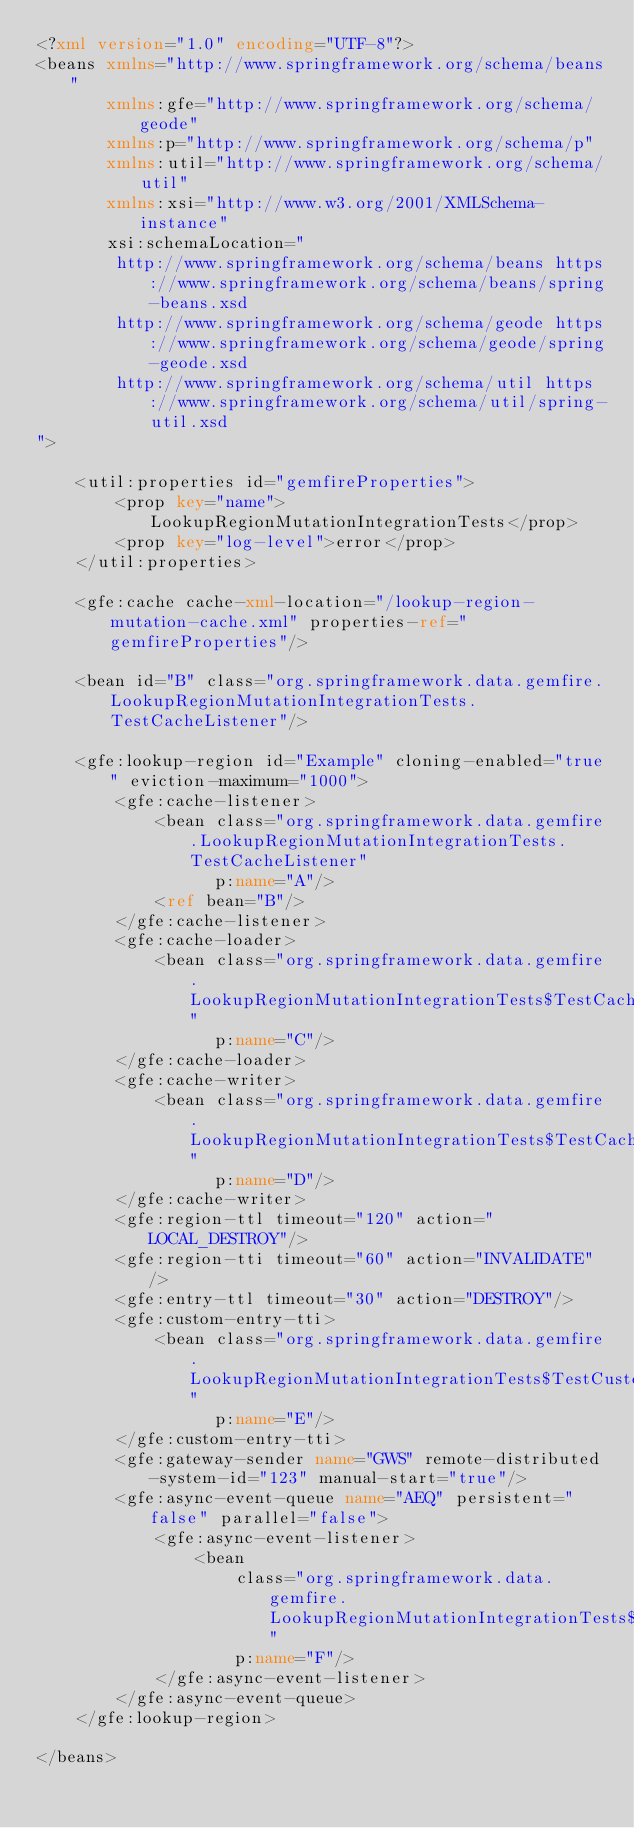<code> <loc_0><loc_0><loc_500><loc_500><_XML_><?xml version="1.0" encoding="UTF-8"?>
<beans xmlns="http://www.springframework.org/schema/beans"
	   xmlns:gfe="http://www.springframework.org/schema/geode"
	   xmlns:p="http://www.springframework.org/schema/p"
	   xmlns:util="http://www.springframework.org/schema/util"
	   xmlns:xsi="http://www.w3.org/2001/XMLSchema-instance"
	   xsi:schemaLocation="
		http://www.springframework.org/schema/beans https://www.springframework.org/schema/beans/spring-beans.xsd
        http://www.springframework.org/schema/geode https://www.springframework.org/schema/geode/spring-geode.xsd
        http://www.springframework.org/schema/util https://www.springframework.org/schema/util/spring-util.xsd
">

	<util:properties id="gemfireProperties">
		<prop key="name">LookupRegionMutationIntegrationTests</prop>
		<prop key="log-level">error</prop>
	</util:properties>

	<gfe:cache cache-xml-location="/lookup-region-mutation-cache.xml" properties-ref="gemfireProperties"/>

	<bean id="B" class="org.springframework.data.gemfire.LookupRegionMutationIntegrationTests.TestCacheListener"/>

	<gfe:lookup-region id="Example" cloning-enabled="true" eviction-maximum="1000">
		<gfe:cache-listener>
			<bean class="org.springframework.data.gemfire.LookupRegionMutationIntegrationTests.TestCacheListener"
				  p:name="A"/>
			<ref bean="B"/>
		</gfe:cache-listener>
		<gfe:cache-loader>
			<bean class="org.springframework.data.gemfire.LookupRegionMutationIntegrationTests$TestCacheLoader"
				  p:name="C"/>
		</gfe:cache-loader>
		<gfe:cache-writer>
			<bean class="org.springframework.data.gemfire.LookupRegionMutationIntegrationTests$TestCacheWriter"
				  p:name="D"/>
		</gfe:cache-writer>
		<gfe:region-ttl timeout="120" action="LOCAL_DESTROY"/>
		<gfe:region-tti timeout="60" action="INVALIDATE"/>
		<gfe:entry-ttl timeout="30" action="DESTROY"/>
		<gfe:custom-entry-tti>
			<bean class="org.springframework.data.gemfire.LookupRegionMutationIntegrationTests$TestCustomExpiry"
				  p:name="E"/>
		</gfe:custom-entry-tti>
		<gfe:gateway-sender name="GWS" remote-distributed-system-id="123" manual-start="true"/>
		<gfe:async-event-queue name="AEQ" persistent="false" parallel="false">
			<gfe:async-event-listener>
				<bean
					class="org.springframework.data.gemfire.LookupRegionMutationIntegrationTests$TestAsyncEventListener"
					p:name="F"/>
			</gfe:async-event-listener>
		</gfe:async-event-queue>
	</gfe:lookup-region>

</beans>
</code> 